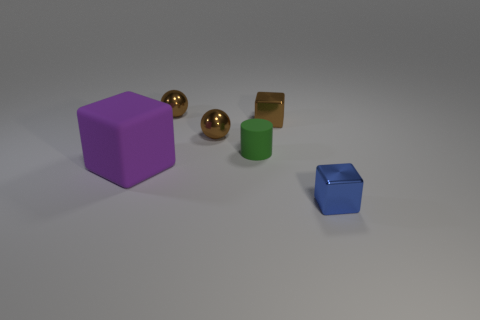What type of materials appear to be represented by these objects? The objects seem to represent a range of materials. The purple block has a matte finish likely indicative of a plastic or painted wood material. The golden spheres have a reflective surface that could suggest a polished metal. The green cylinder has a less reflective, more diffuse surface that also looks like it could be plastic, and the small blue cube appears to have a reflective, slightly metallic texture. 